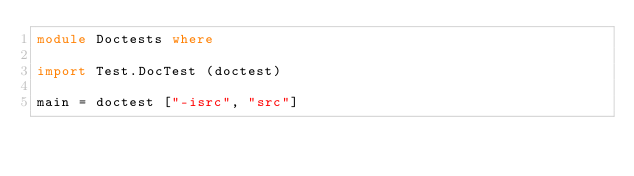Convert code to text. <code><loc_0><loc_0><loc_500><loc_500><_Haskell_>module Doctests where

import Test.DocTest (doctest)

main = doctest ["-isrc", "src"]</code> 